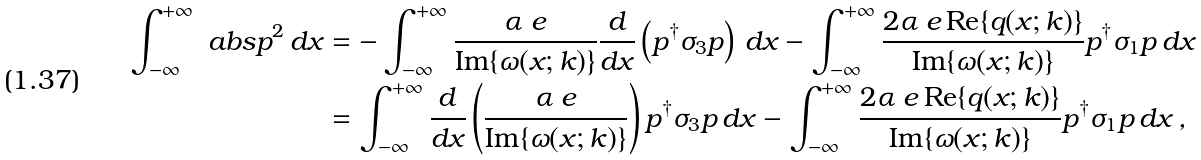<formula> <loc_0><loc_0><loc_500><loc_500>\int _ { - \infty } ^ { + \infty } \ a b s { p } ^ { 2 } \, d x & = - \int _ { - \infty } ^ { + \infty } \frac { \alpha \ e } { \text {Im} \{ \omega ( x ; k ) \} } \frac { d } { d x } \left ( p ^ { \dagger } \sigma _ { 3 } p \right ) \, d x - \int _ { - \infty } ^ { + \infty } \frac { 2 \alpha \ e \, \text {Re} \{ q ( x ; k ) \} } { \text {Im} \{ \omega ( x ; k ) \} } p ^ { \dagger } \sigma _ { 1 } p \, d x \\ & = \int _ { - \infty } ^ { + \infty } \frac { d } { d x } \left ( \frac { \alpha \ e } { \text {Im} \{ \omega ( x ; k ) \} } \right ) p ^ { \dagger } \sigma _ { 3 } p \, d x - \int _ { - \infty } ^ { + \infty } \frac { 2 \alpha \ e \, \text {Re} \{ q ( x ; k ) \} } { \text {Im} \{ \omega ( x ; k ) \} } p ^ { \dagger } \sigma _ { 1 } p \, d x \, ,</formula> 